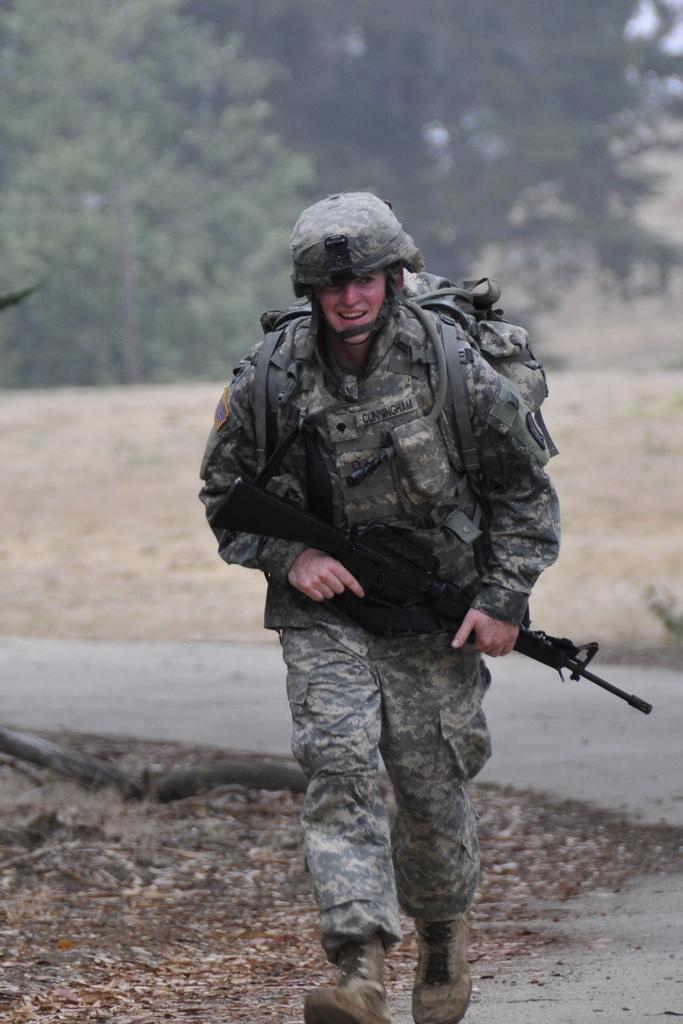Please provide a concise description of this image. There is one man running and holding a gun and wearing a backpack in the middle of this image. There are trees in the background. 